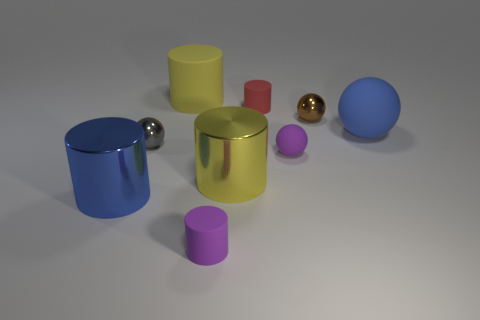How many other rubber spheres have the same color as the large matte sphere?
Your answer should be compact. 0. What is the material of the tiny object that is behind the shiny sphere right of the tiny gray object?
Offer a terse response. Rubber. What size is the gray sphere?
Your response must be concise. Small. What number of purple spheres are the same size as the purple cylinder?
Make the answer very short. 1. What number of blue things are the same shape as the yellow metal object?
Make the answer very short. 1. Are there an equal number of small brown balls on the left side of the tiny brown thing and blue balls?
Keep it short and to the point. No. The gray object that is the same size as the red matte object is what shape?
Offer a terse response. Sphere. Are there any other big rubber objects of the same shape as the gray object?
Offer a terse response. Yes. There is a large yellow cylinder to the left of the yellow thing in front of the tiny red rubber object; are there any tiny brown objects behind it?
Make the answer very short. No. Is the number of tiny purple rubber cylinders that are behind the blue sphere greater than the number of red matte things in front of the small purple matte cylinder?
Your answer should be compact. No. 